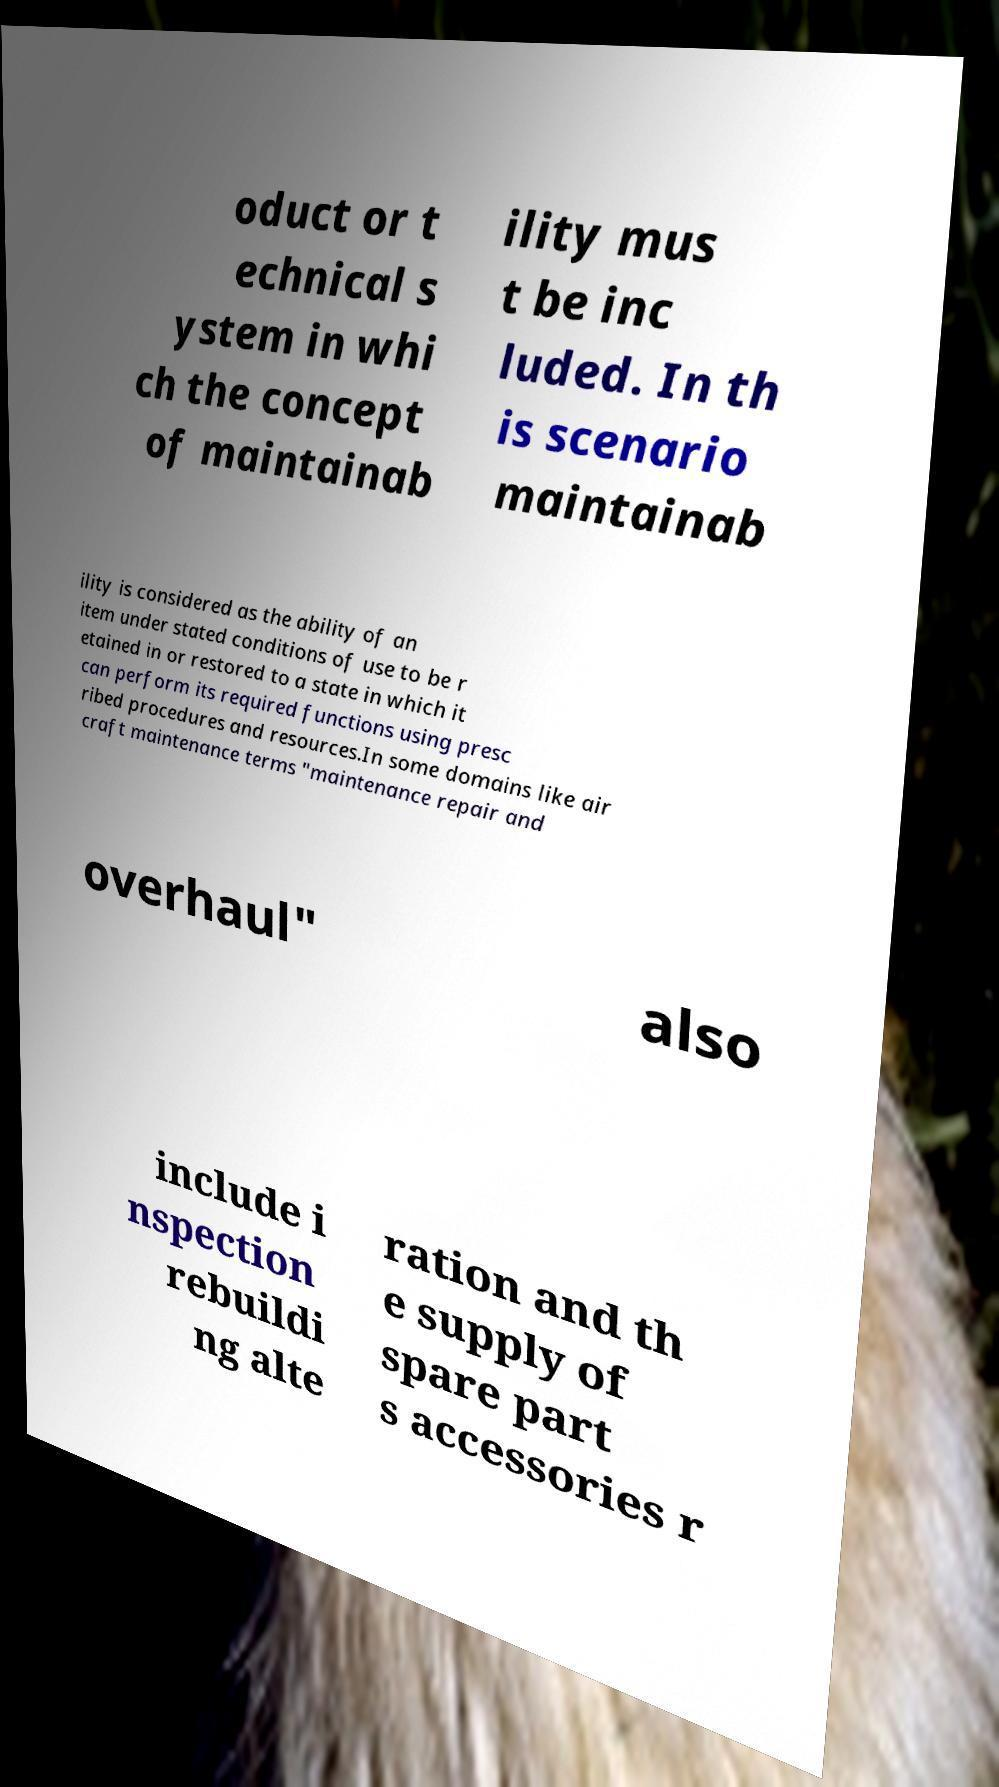There's text embedded in this image that I need extracted. Can you transcribe it verbatim? oduct or t echnical s ystem in whi ch the concept of maintainab ility mus t be inc luded. In th is scenario maintainab ility is considered as the ability of an item under stated conditions of use to be r etained in or restored to a state in which it can perform its required functions using presc ribed procedures and resources.In some domains like air craft maintenance terms "maintenance repair and overhaul" also include i nspection rebuildi ng alte ration and th e supply of spare part s accessories r 